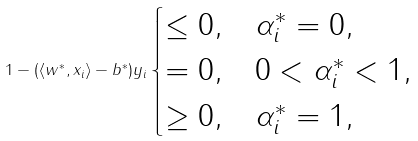Convert formula to latex. <formula><loc_0><loc_0><loc_500><loc_500>1 - ( \langle w ^ { * } , x _ { i } \rangle - b ^ { * } ) y _ { i } \begin{cases} \leq 0 , & \alpha ^ { * } _ { i } = 0 , \\ = 0 , & 0 < \alpha ^ { * } _ { i } < 1 , \\ \geq 0 , & \alpha ^ { * } _ { i } = 1 , \end{cases}</formula> 